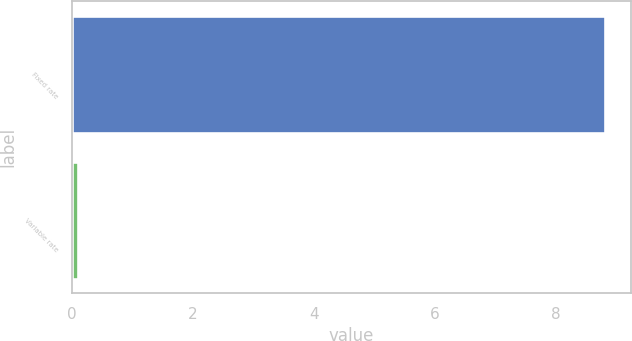Convert chart. <chart><loc_0><loc_0><loc_500><loc_500><bar_chart><fcel>Fixed rate<fcel>Variable rate<nl><fcel>8.8<fcel>0.1<nl></chart> 